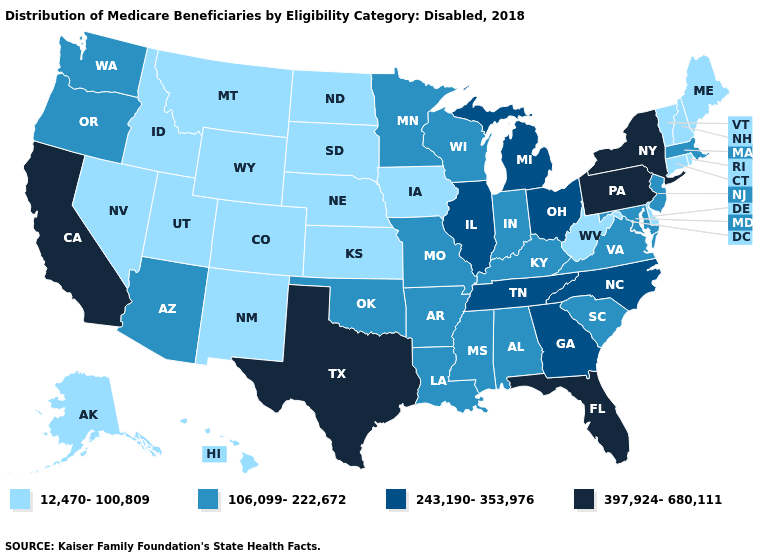Name the states that have a value in the range 106,099-222,672?
Short answer required. Alabama, Arizona, Arkansas, Indiana, Kentucky, Louisiana, Maryland, Massachusetts, Minnesota, Mississippi, Missouri, New Jersey, Oklahoma, Oregon, South Carolina, Virginia, Washington, Wisconsin. Name the states that have a value in the range 106,099-222,672?
Be succinct. Alabama, Arizona, Arkansas, Indiana, Kentucky, Louisiana, Maryland, Massachusetts, Minnesota, Mississippi, Missouri, New Jersey, Oklahoma, Oregon, South Carolina, Virginia, Washington, Wisconsin. Does the map have missing data?
Write a very short answer. No. Among the states that border Arizona , does Nevada have the highest value?
Keep it brief. No. Does Georgia have the lowest value in the USA?
Give a very brief answer. No. Which states have the lowest value in the USA?
Short answer required. Alaska, Colorado, Connecticut, Delaware, Hawaii, Idaho, Iowa, Kansas, Maine, Montana, Nebraska, Nevada, New Hampshire, New Mexico, North Dakota, Rhode Island, South Dakota, Utah, Vermont, West Virginia, Wyoming. What is the lowest value in states that border Rhode Island?
Short answer required. 12,470-100,809. Name the states that have a value in the range 397,924-680,111?
Be succinct. California, Florida, New York, Pennsylvania, Texas. What is the value of Alabama?
Answer briefly. 106,099-222,672. What is the value of Arizona?
Answer briefly. 106,099-222,672. What is the lowest value in the USA?
Write a very short answer. 12,470-100,809. Among the states that border Georgia , does South Carolina have the lowest value?
Concise answer only. Yes. Does Louisiana have the lowest value in the USA?
Short answer required. No. Among the states that border Nebraska , does Missouri have the lowest value?
Write a very short answer. No. Does the map have missing data?
Be succinct. No. 